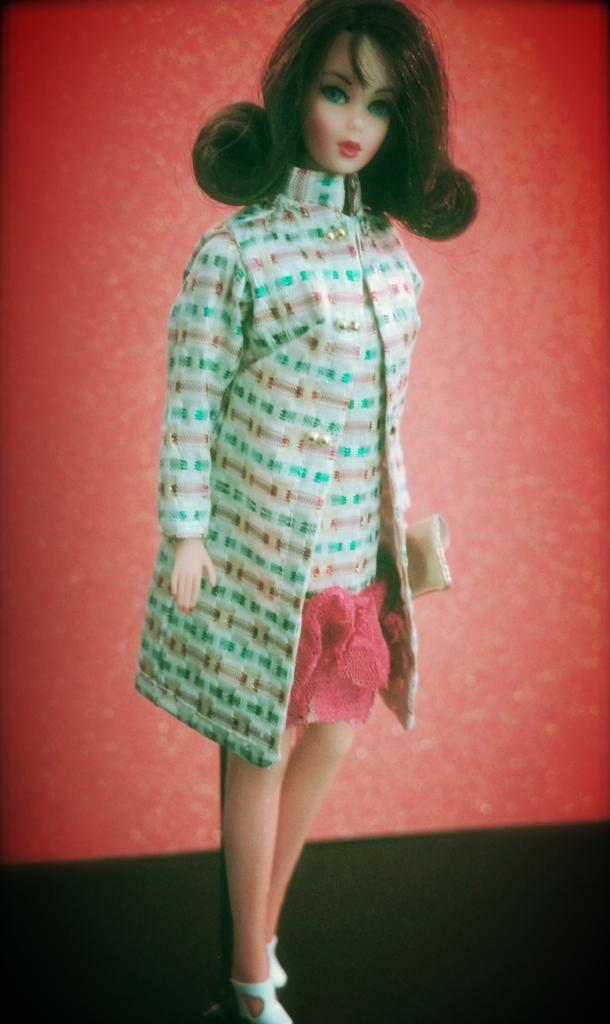What is placed on the surface in the image? There is a doll on the surface in the image. What color is the background of the image? The background of the image is red. Is there a stage visible in the image? There is no stage present in the image. 